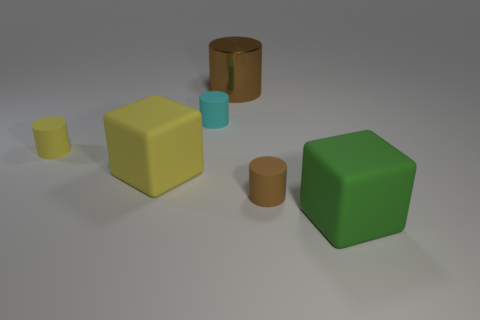Are the shapes in any specific arrangement or pattern? The shapes seem to be arranged in a somewhat loose and random pattern, without an apparent intentional order. The objects might slightly suggest a diagonal line from the top-left to the bottom-right of the image. 